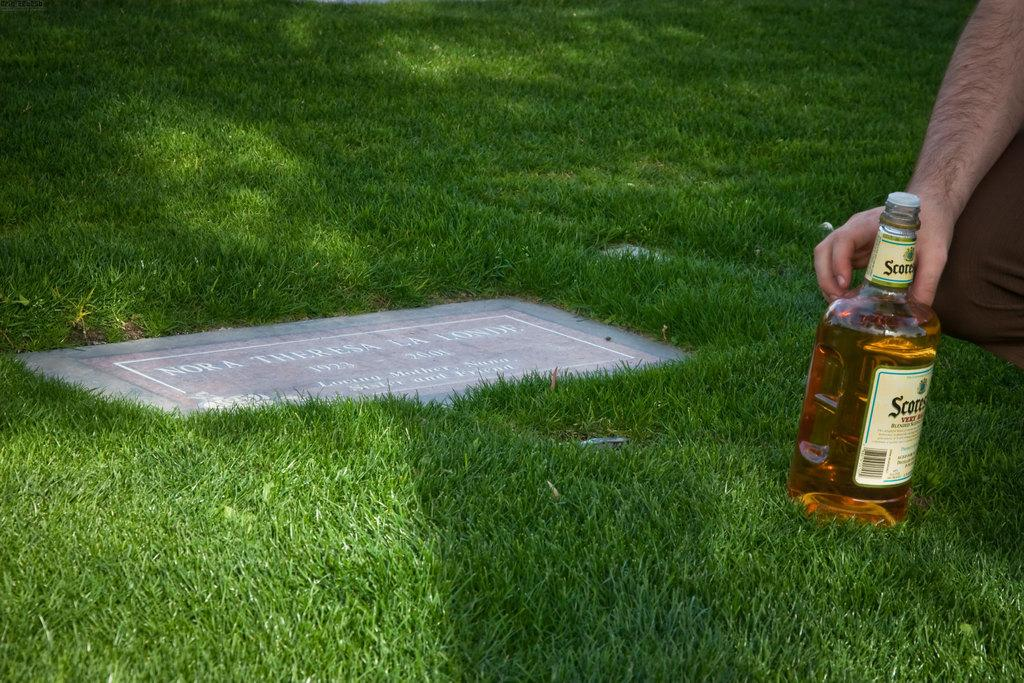What part of the human body is visible in the image? There is a human hand in the image. What object is present in the image alongside the hand? There is a bottle in the image. What surface is the hand and bottle placed on in the image? There is a board in the image. What type of natural environment is visible in the image? There is grass in the image. What type of attack is being carried out in the image? There is no attack present in the image. 